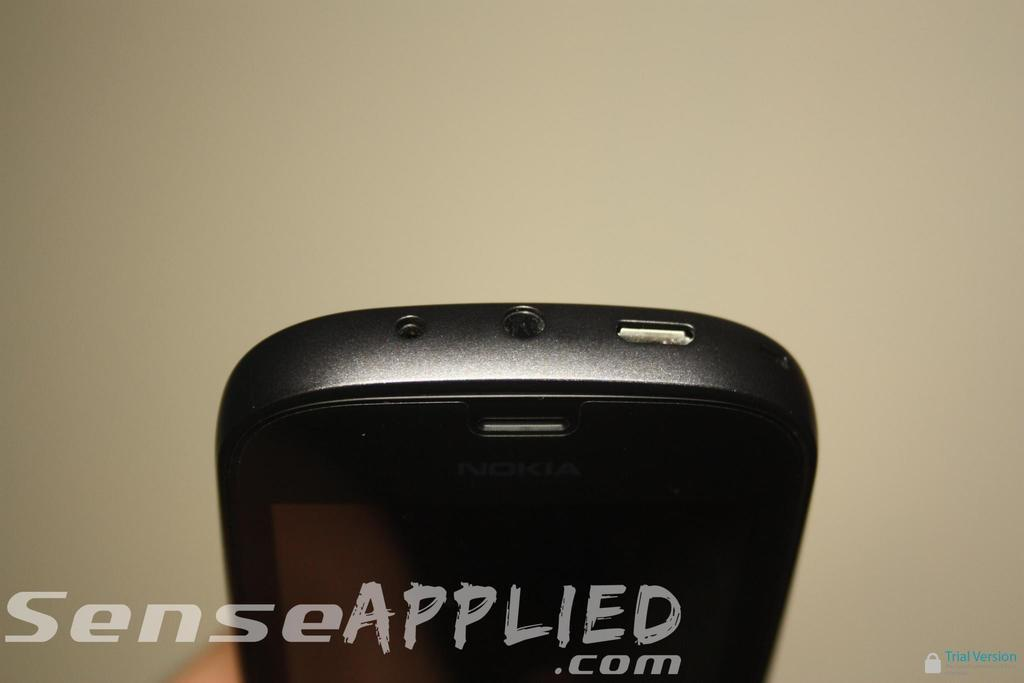<image>
Create a compact narrative representing the image presented. Nokia smartphone that has the text on the bottom left that says SenseApplied.com. 